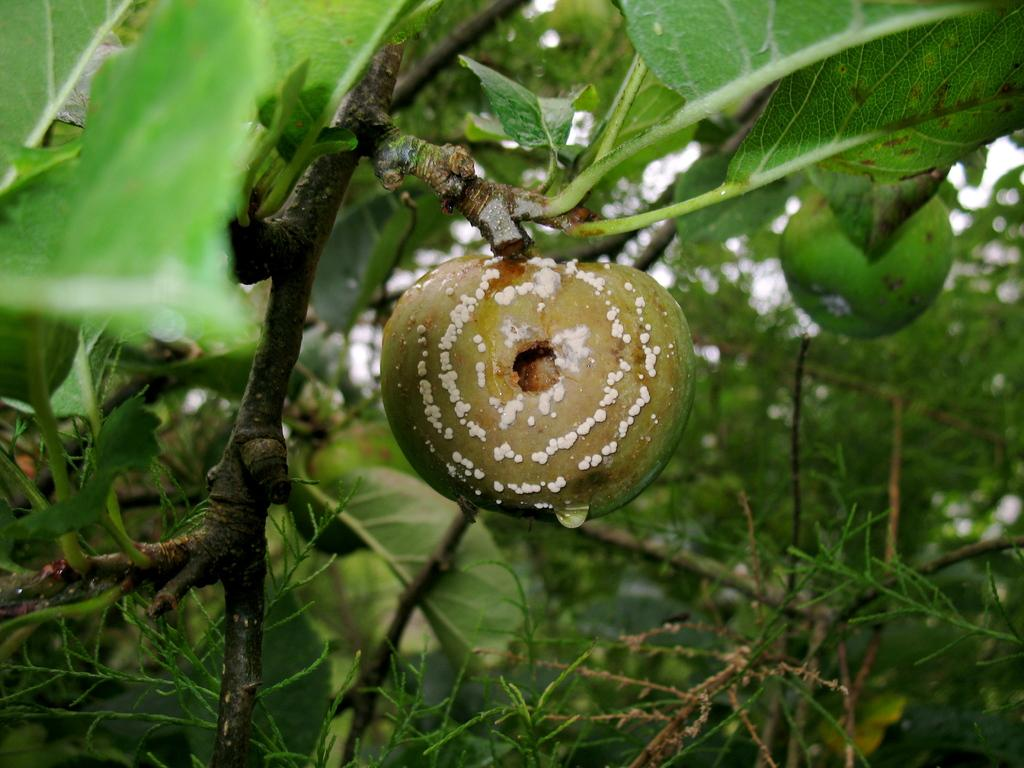What is the main subject of the image? The main subject of the image is a plant with a fruit in the center. What can be seen in the background of the image? There are trees in the background of the image. What type of game is being played in the image? There is no game being played in the image; it features a plant with a fruit and trees in the background. What nation is depicted in the image? The image does not depict a specific nation; it focuses on a plant with a fruit and trees in the background. 